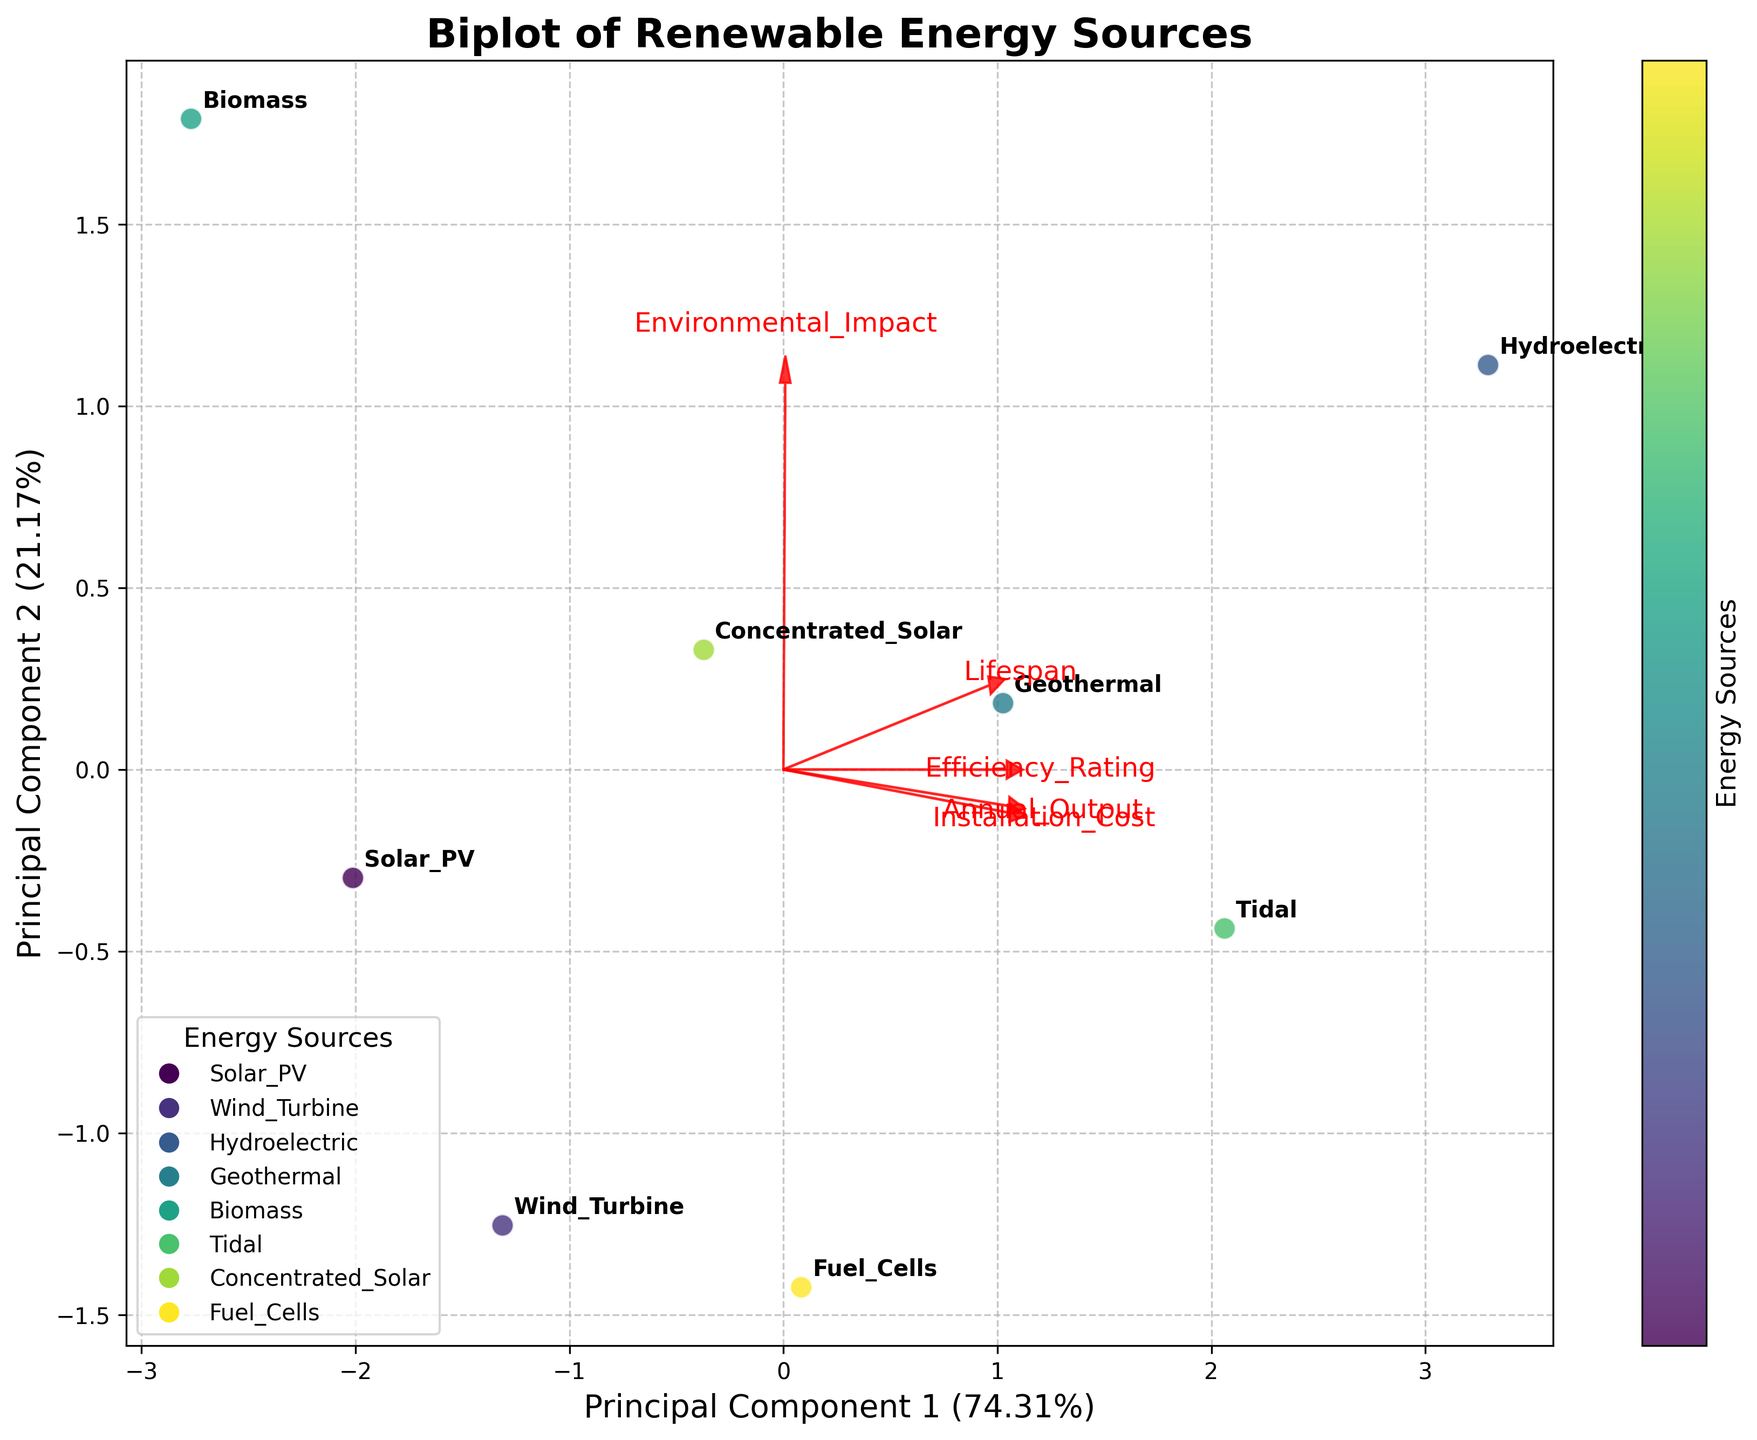What is the title of the figure? The title is located at the top of the figure, usually providing a summary of what the figure represents.
Answer: Biplot of Renewable Energy Sources How many energy sources are analyzed in the figure? Each energy source is represented by a unique label on the plot, and we count the total number of these labels.
Answer: 8 Which energy source is located the farthest to the right along the x-axis? We find the point that is positioned the furthest to the right on the x-axis, indicating the highest first principal component value.
Answer: Wind Turbine Which energy source has the highest efficiency rating based on the provided data? Referring to the data table, we look for the highest value in the Efficiency_Rating column.
Answer: Hydroelectric Which energy source has the highest second principal component value? We locate the point with the highest vertical position on the y-axis, which represents the second principal component.
Answer: Geothermal How is the lifespan of renewable energy sources represented in the biplot? Lifespan is shown as a vector originating from the center, labeled on the plot. Its direction and length indicate its relationship with the principal components.
Answer: As a labeled vector Which two energy sources have the most similar positions in the biplot? By visually comparing the distances and positions of points in the plot, the two points closest to each other represent the most similar sources.
Answer: Biomass and Solar PV What does the length of the red arrows indicate in the biplot? The length of the arrows, or vectors, represents the importance of each feature in explaining the variability in the data. Longer arrows indicate features that have a greater contribution to the principal components.
Answer: Importance of each feature Which feature has the largest impact on the first principal component? By identifying the arrow with the longest projection on the x-axis, we can determine which feature most heavily influences the first principal component.
Answer: Installation Cost How does the environmental impact ranking of Hydroelectric compare to other sources? By observing the direction and length of the Environmental Impact vector and the position of Hydroelectric, we can compare its alignment relative to others.
Answer: Higher environmental impact 